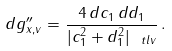<formula> <loc_0><loc_0><loc_500><loc_500>d g ^ { \prime \prime } _ { x , v } = \frac { 4 \, d c _ { 1 } \, d d _ { 1 } } { | c _ { 1 } ^ { 2 } + d _ { 1 } ^ { 2 } | _ { \ t l { v } } } \, .</formula> 